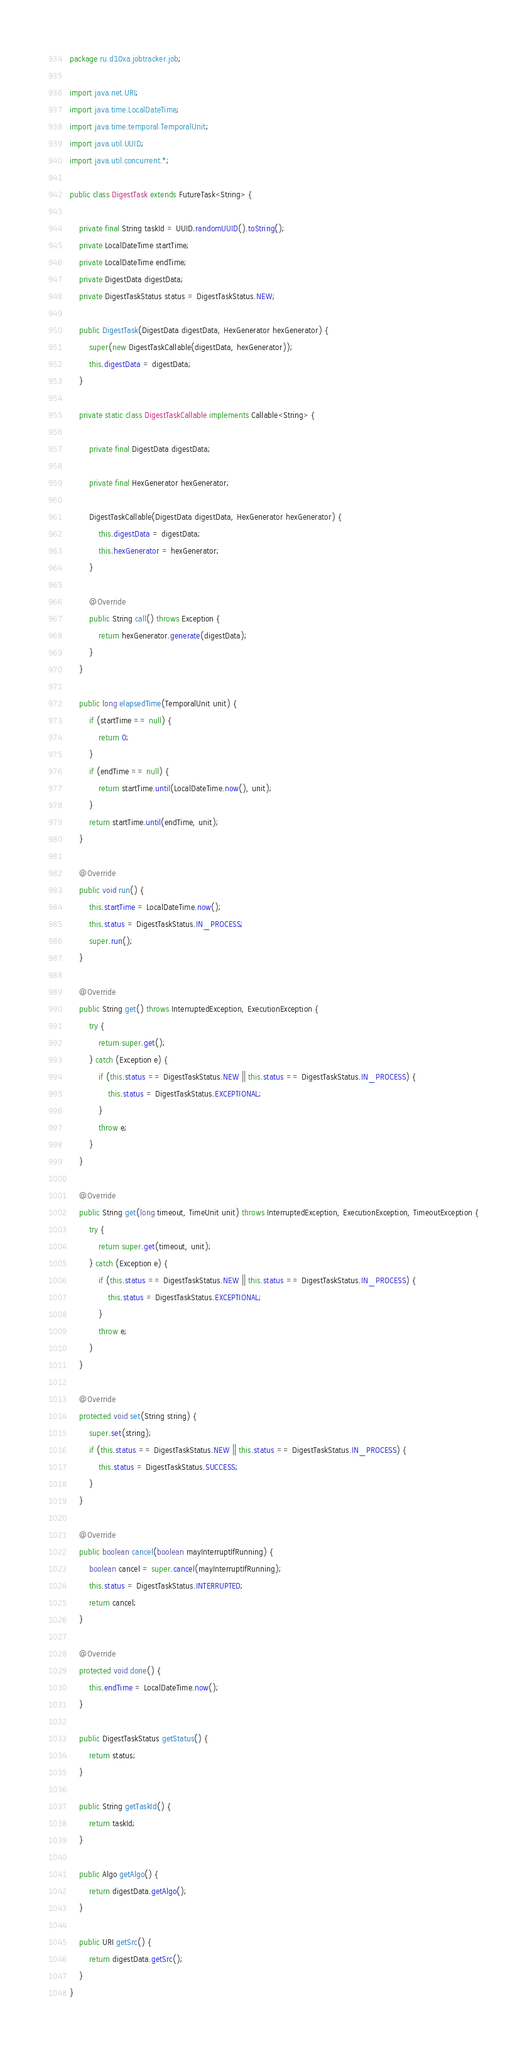Convert code to text. <code><loc_0><loc_0><loc_500><loc_500><_Java_>package ru.d10xa.jobtracker.job;

import java.net.URI;
import java.time.LocalDateTime;
import java.time.temporal.TemporalUnit;
import java.util.UUID;
import java.util.concurrent.*;

public class DigestTask extends FutureTask<String> {

    private final String taskId = UUID.randomUUID().toString();
    private LocalDateTime startTime;
    private LocalDateTime endTime;
    private DigestData digestData;
    private DigestTaskStatus status = DigestTaskStatus.NEW;

    public DigestTask(DigestData digestData, HexGenerator hexGenerator) {
        super(new DigestTaskCallable(digestData, hexGenerator));
        this.digestData = digestData;
    }

    private static class DigestTaskCallable implements Callable<String> {

        private final DigestData digestData;

        private final HexGenerator hexGenerator;

        DigestTaskCallable(DigestData digestData, HexGenerator hexGenerator) {
            this.digestData = digestData;
            this.hexGenerator = hexGenerator;
        }

        @Override
        public String call() throws Exception {
            return hexGenerator.generate(digestData);
        }
    }

    public long elapsedTime(TemporalUnit unit) {
        if (startTime == null) {
            return 0;
        }
        if (endTime == null) {
            return startTime.until(LocalDateTime.now(), unit);
        }
        return startTime.until(endTime, unit);
    }

    @Override
    public void run() {
        this.startTime = LocalDateTime.now();
        this.status = DigestTaskStatus.IN_PROCESS;
        super.run();
    }

    @Override
    public String get() throws InterruptedException, ExecutionException {
        try {
            return super.get();
        } catch (Exception e) {
            if (this.status == DigestTaskStatus.NEW || this.status == DigestTaskStatus.IN_PROCESS) {
                this.status = DigestTaskStatus.EXCEPTIONAL;
            }
            throw e;
        }
    }

    @Override
    public String get(long timeout, TimeUnit unit) throws InterruptedException, ExecutionException, TimeoutException {
        try {
            return super.get(timeout, unit);
        } catch (Exception e) {
            if (this.status == DigestTaskStatus.NEW || this.status == DigestTaskStatus.IN_PROCESS) {
                this.status = DigestTaskStatus.EXCEPTIONAL;
            }
            throw e;
        }
    }

    @Override
    protected void set(String string) {
        super.set(string);
        if (this.status == DigestTaskStatus.NEW || this.status == DigestTaskStatus.IN_PROCESS) {
            this.status = DigestTaskStatus.SUCCESS;
        }
    }

    @Override
    public boolean cancel(boolean mayInterruptIfRunning) {
        boolean cancel = super.cancel(mayInterruptIfRunning);
        this.status = DigestTaskStatus.INTERRUPTED;
        return cancel;
    }

    @Override
    protected void done() {
        this.endTime = LocalDateTime.now();
    }

    public DigestTaskStatus getStatus() {
        return status;
    }

    public String getTaskId() {
        return taskId;
    }

    public Algo getAlgo() {
        return digestData.getAlgo();
    }

    public URI getSrc() {
        return digestData.getSrc();
    }
}
</code> 